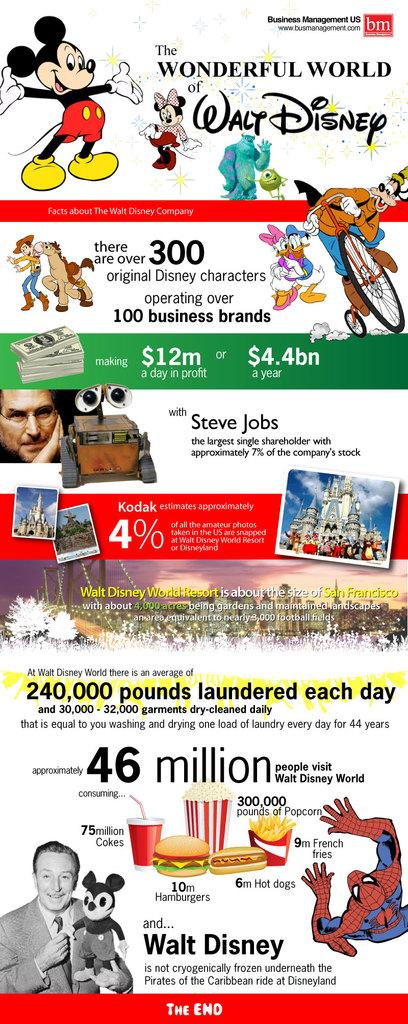What type of visual is depicted in the image? The image appears to be a poster. What is the purpose of the poster? The poster seems to be an advertisement. What type of content is featured on the poster? There are animated series images on the poster. Can you describe the person's image at the bottom of the poster? Yes, there is a person's image at the bottom of the poster. How many buildings are visible in the image? There are no buildings visible in the image; it is a poster featuring animated series images and a person's image. How many visitors are present in the image? There are no visitors present in the image; it is a poster with animated series images and a person's image. 